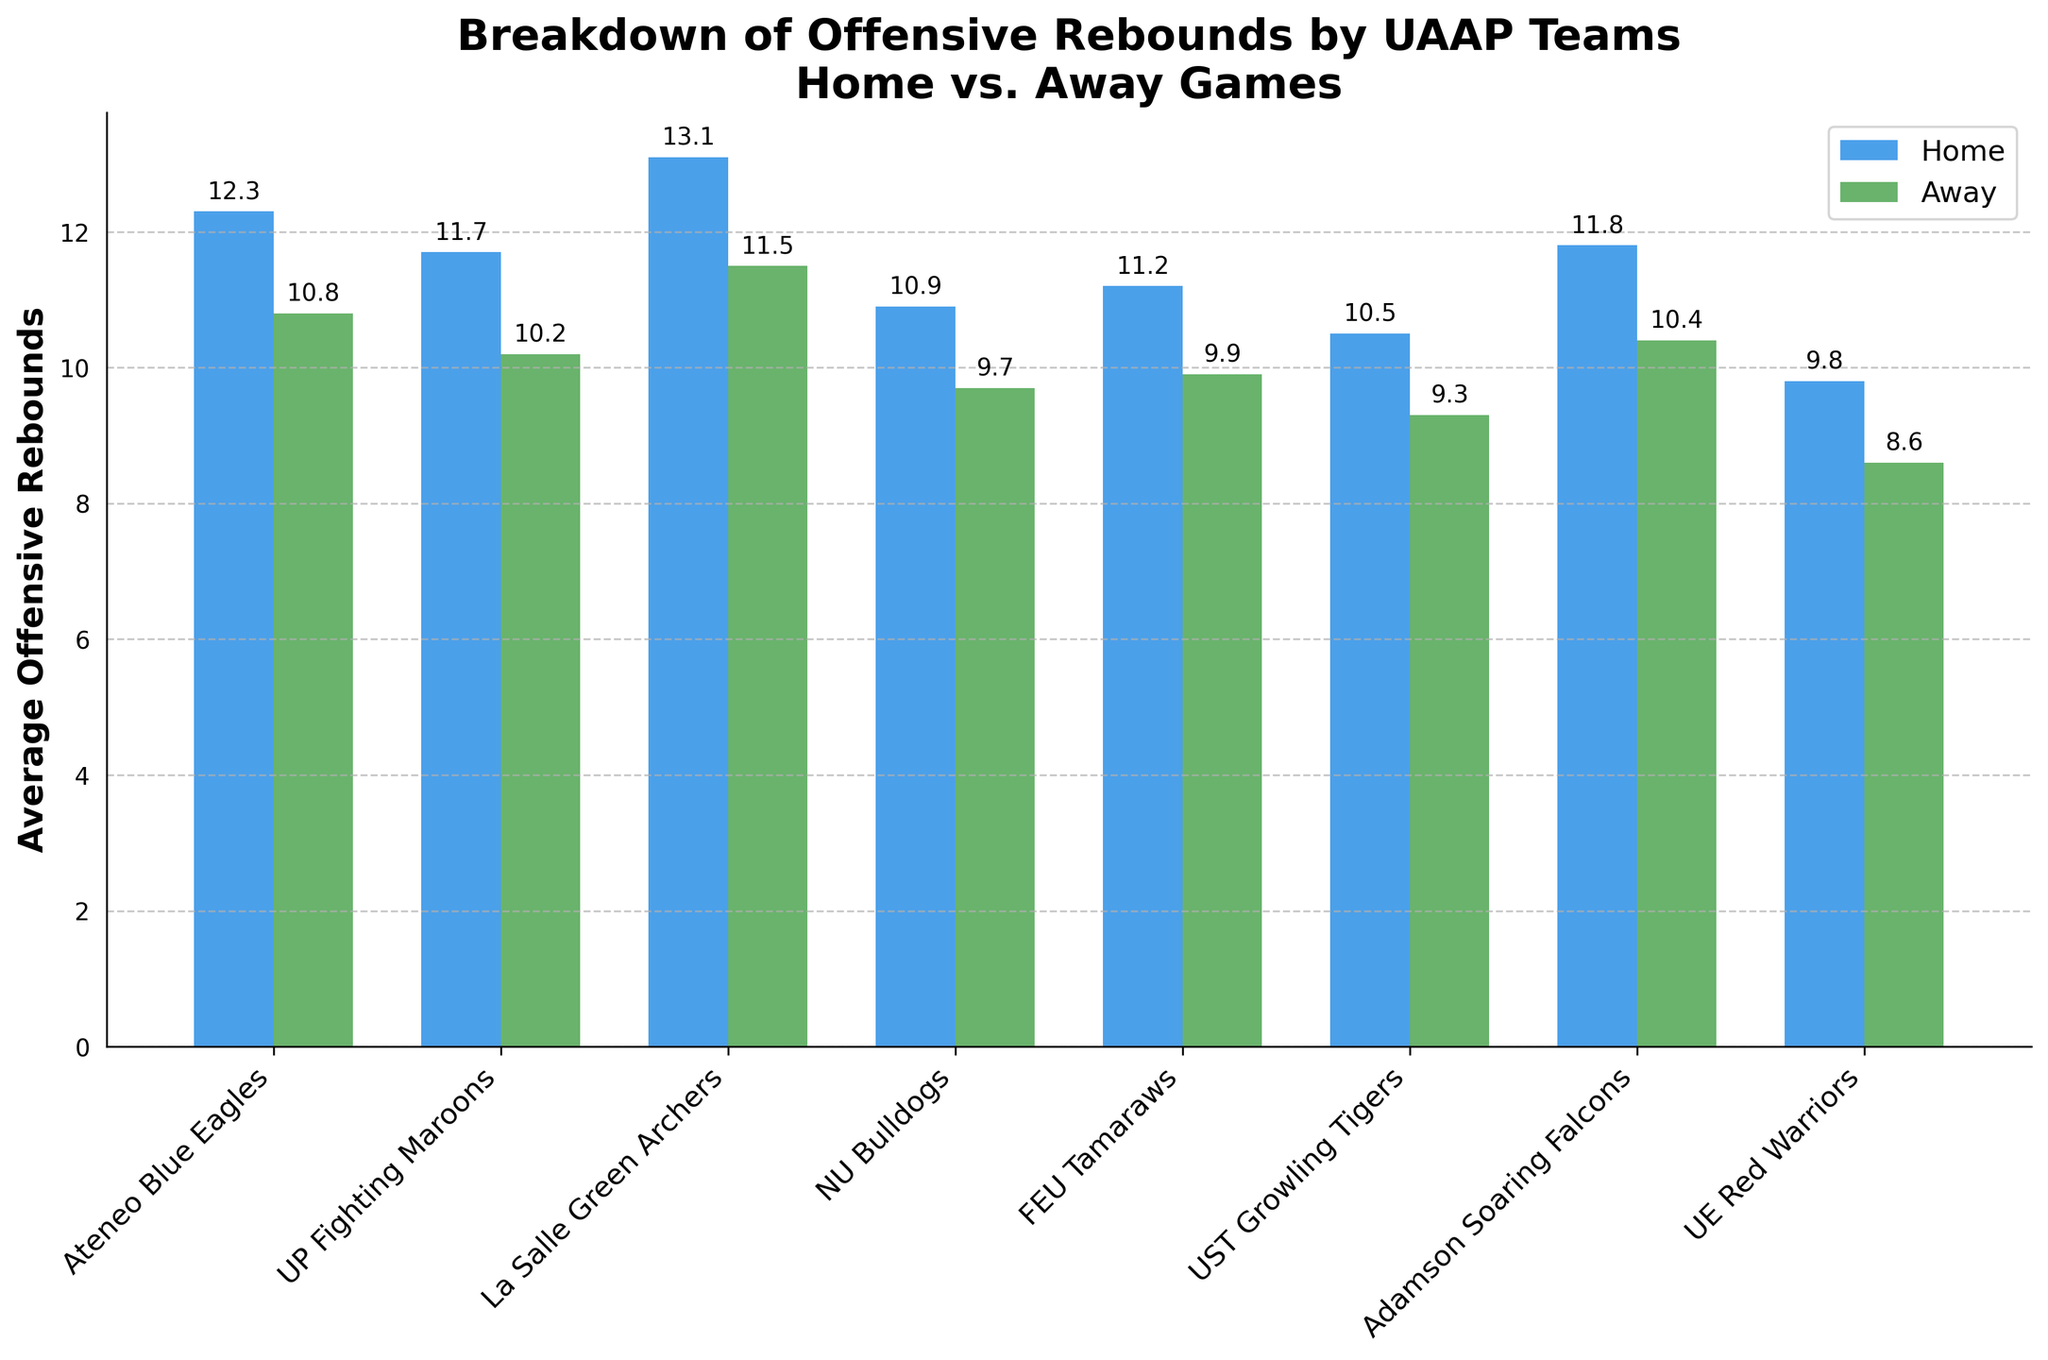Which team has the highest average number of offensive rebounds in home games? The Ateneo Blue Eagles have an average of 12.3 offensive rebounds at home, which is higher than any other team.
Answer: Ateneo Blue Eagles Which team has the smallest difference between home and away offensive rebounds? The Adamson Soaring Falcons have a difference of 1.4 rebounds (11.8 at home - 10.4 away), which is the smallest among all teams.
Answer: Adamson Soaring Falcons For La Salle Green Archers, how many more offensive rebounds do they get at home compared to away games? The difference in average rebounds is calculated by subtracting away rebounds from home rebounds for La Salle Green Archers: 13.1 - 11.5 = 1.6.
Answer: 1.6 Compare the average offensive rebounds at home for UP Fighting Maroons and UST Growling Tigers. Which team has more? UP Fighting Maroons have an average of 11.7 offensive rebounds at home, whereas UST Growling Tigers have 10.5. UP Fighting Maroons have more.
Answer: UP Fighting Maroons What's the average number of offensive rebounds for NU Bulldogs when combining home and away numbers? The average is calculated by taking the sum of home and away rebounds and dividing by 2 for NU Bulldogs: (10.9 + 9.7) / 2 = 10.3.
Answer: 10.3 How many teams have more than 11 offensive rebounds on average in away games? UP Fighting Maroons (10.2), La Salle Green Archers (11.5), Adamson Soaring Falcons (10.4), and Ateneo Blue Eagles (10.8). Only La Salle Green Archers have more than 11 rebounds away.
Answer: 1 team Which team has the lowest average number of offensive rebounds in away games? The UE Red Warriors have the lowest average number of away offensive rebounds with 8.6.
Answer: UE Red Warriors 